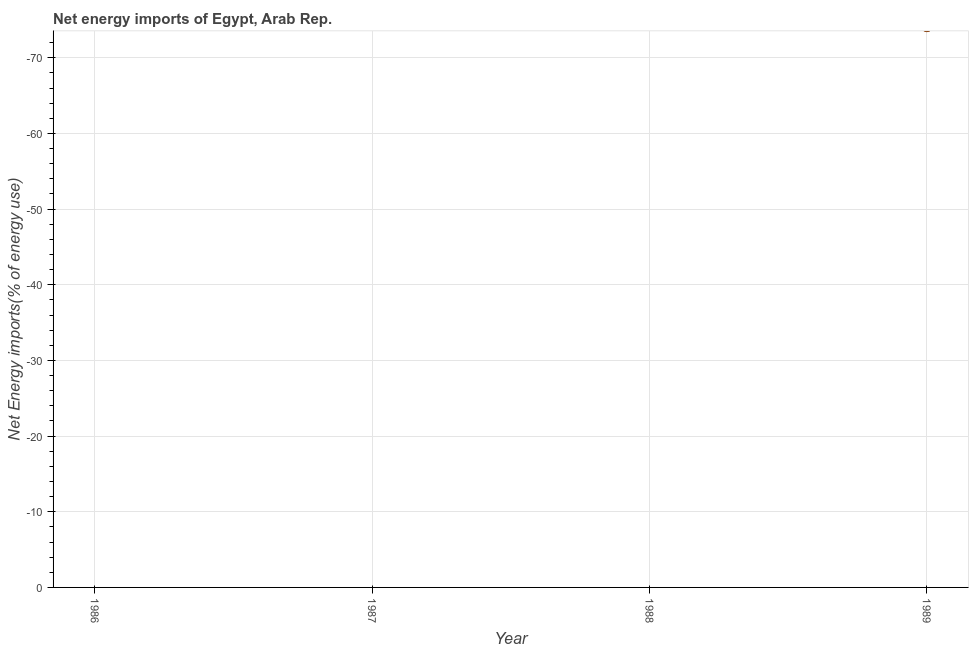Across all years, what is the minimum energy imports?
Provide a short and direct response. 0. What is the average energy imports per year?
Provide a short and direct response. 0. In how many years, is the energy imports greater than -2 %?
Ensure brevity in your answer.  0. In how many years, is the energy imports greater than the average energy imports taken over all years?
Your response must be concise. 0. Does the energy imports monotonically increase over the years?
Ensure brevity in your answer.  No. How many dotlines are there?
Make the answer very short. 0. What is the difference between two consecutive major ticks on the Y-axis?
Ensure brevity in your answer.  10. Does the graph contain grids?
Your response must be concise. Yes. What is the title of the graph?
Provide a succinct answer. Net energy imports of Egypt, Arab Rep. What is the label or title of the Y-axis?
Your answer should be compact. Net Energy imports(% of energy use). What is the Net Energy imports(% of energy use) in 1986?
Your response must be concise. 0. What is the Net Energy imports(% of energy use) in 1987?
Your response must be concise. 0. What is the Net Energy imports(% of energy use) in 1988?
Your answer should be very brief. 0. 